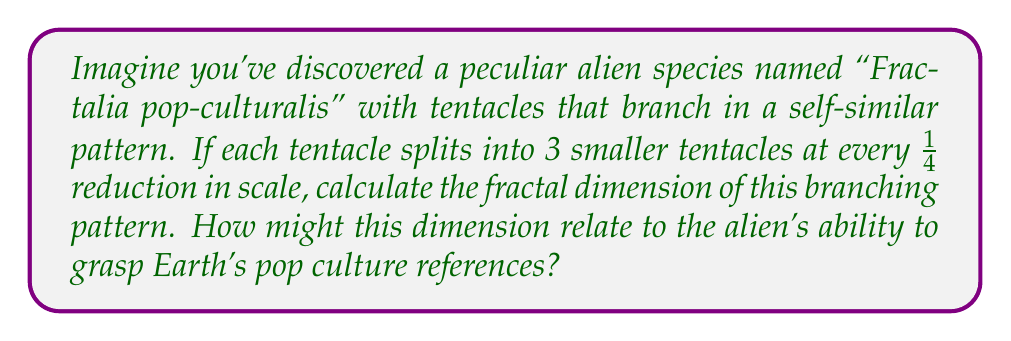Could you help me with this problem? To calculate the fractal dimension of the "Fractalia pop-culturalis" tentacle branching pattern, we'll use the box-counting dimension formula:

$$D = \frac{\log N}{\log (1/r)}$$

Where:
- $D$ is the fractal dimension
- $N$ is the number of self-similar pieces
- $r$ is the scaling factor

Step 1: Identify the number of self-similar pieces ($N$).
In this case, each tentacle splits into 3 smaller tentacles, so $N = 3$.

Step 2: Identify the scaling factor ($r$).
The tentacles split at every 1/4 reduction in scale, so $r = 1/4$.

Step 3: Plug the values into the formula:

$$D = \frac{\log 3}{\log (1/(1/4))} = \frac{\log 3}{\log 4}$$

Step 4: Calculate the result:

$$D = \frac{\log 3}{\log 4} \approx 1.2618595071429148$$

The fractal dimension of the alien species' branching pattern is approximately 1.26.

This non-integer dimension between 1 and 2 suggests a complex, space-filling pattern that's more intricate than a simple line (dimension 1) but doesn't quite fill a plane (dimension 2). 

Whimsically, we might speculate that this fractal dimension could relate to the alien's ability to grasp Earth's pop culture references. A dimension of 1.26 might indicate a moderate capacity for understanding and connecting diverse cultural concepts, much like how the branching tentacles create intricate, interconnected patterns. Perhaps "Fractalia pop-culturalis" can grasp about 126% of the pop culture references a typical Earth creature might understand!
Answer: $D = \frac{\log 3}{\log 4} \approx 1.26$ 